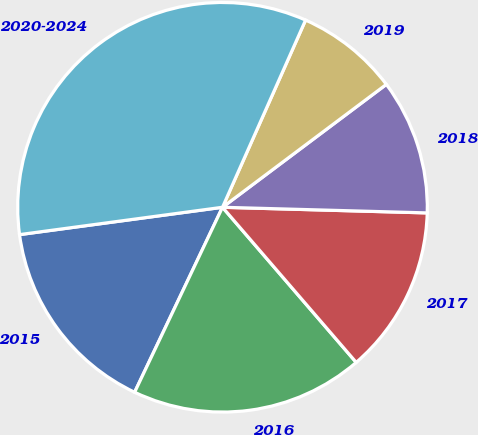Convert chart to OTSL. <chart><loc_0><loc_0><loc_500><loc_500><pie_chart><fcel>2015<fcel>2016<fcel>2017<fcel>2018<fcel>2019<fcel>2020-2024<nl><fcel>15.81%<fcel>18.38%<fcel>13.24%<fcel>10.68%<fcel>8.11%<fcel>33.78%<nl></chart> 